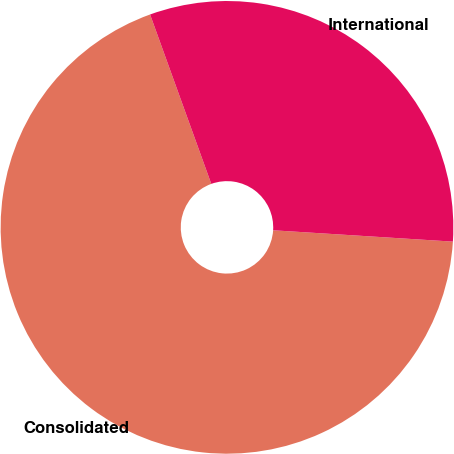Convert chart to OTSL. <chart><loc_0><loc_0><loc_500><loc_500><pie_chart><fcel>Consolidated<fcel>International<nl><fcel>68.48%<fcel>31.52%<nl></chart> 